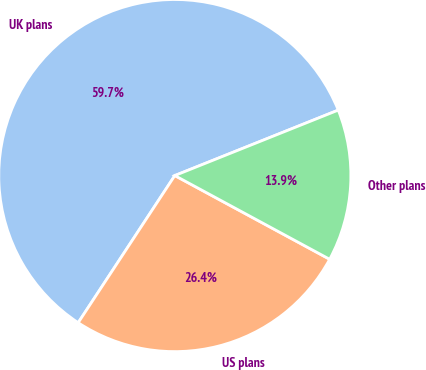<chart> <loc_0><loc_0><loc_500><loc_500><pie_chart><fcel>UK plans<fcel>US plans<fcel>Other plans<nl><fcel>59.69%<fcel>26.36%<fcel>13.95%<nl></chart> 